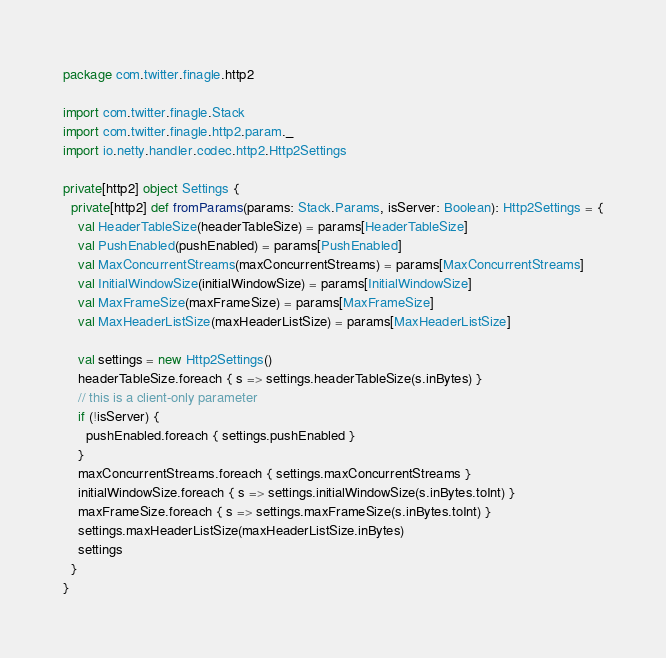<code> <loc_0><loc_0><loc_500><loc_500><_Scala_>package com.twitter.finagle.http2

import com.twitter.finagle.Stack
import com.twitter.finagle.http2.param._
import io.netty.handler.codec.http2.Http2Settings

private[http2] object Settings {
  private[http2] def fromParams(params: Stack.Params, isServer: Boolean): Http2Settings = {
    val HeaderTableSize(headerTableSize) = params[HeaderTableSize]
    val PushEnabled(pushEnabled) = params[PushEnabled]
    val MaxConcurrentStreams(maxConcurrentStreams) = params[MaxConcurrentStreams]
    val InitialWindowSize(initialWindowSize) = params[InitialWindowSize]
    val MaxFrameSize(maxFrameSize) = params[MaxFrameSize]
    val MaxHeaderListSize(maxHeaderListSize) = params[MaxHeaderListSize]

    val settings = new Http2Settings()
    headerTableSize.foreach { s => settings.headerTableSize(s.inBytes) }
    // this is a client-only parameter
    if (!isServer) {
      pushEnabled.foreach { settings.pushEnabled }
    }
    maxConcurrentStreams.foreach { settings.maxConcurrentStreams }
    initialWindowSize.foreach { s => settings.initialWindowSize(s.inBytes.toInt) }
    maxFrameSize.foreach { s => settings.maxFrameSize(s.inBytes.toInt) }
    settings.maxHeaderListSize(maxHeaderListSize.inBytes)
    settings
  }
}
</code> 